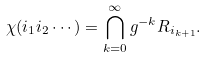<formula> <loc_0><loc_0><loc_500><loc_500>\chi ( i _ { 1 } i _ { 2 } \cdots ) = \bigcap _ { k = 0 } ^ { \infty } g ^ { - k } R _ { i _ { k + 1 } } .</formula> 